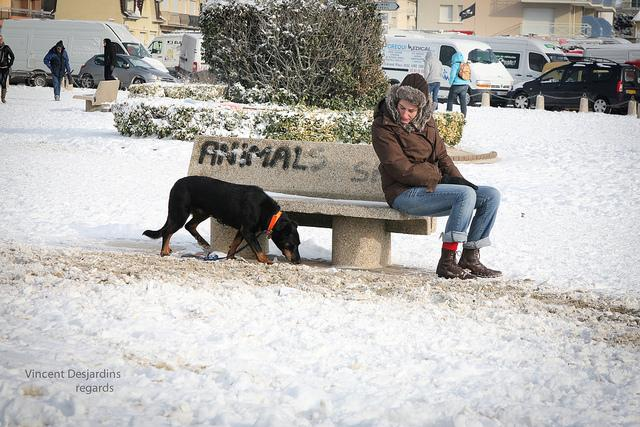What physical danger could she face if she was stuck in the cold with no winter apparel? hypothermia 